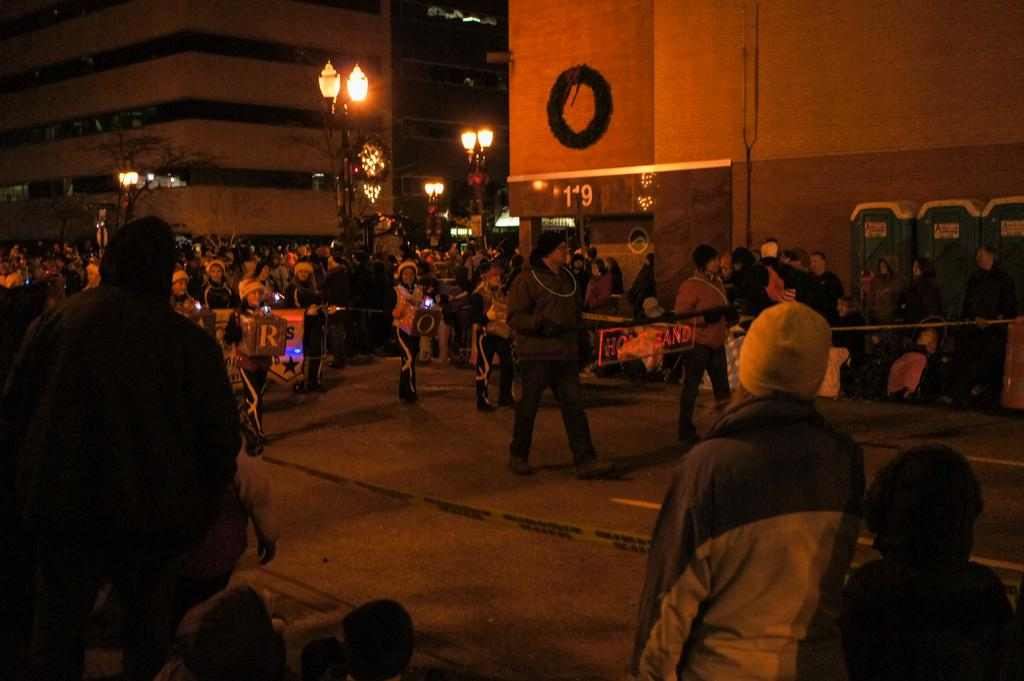What can be seen on the right side of the road in the image? There are persons standing on the right side of the road. What is located in the middle of the image? There are lights and buildings in the middle of the image. What type of statement can be seen written on the buildings in the image? There are no statements visible on the buildings in the image; only lights and buildings are present. Can you tell me how many houses are depicted in the image? There is no house present in the image; it features lights and buildings. 